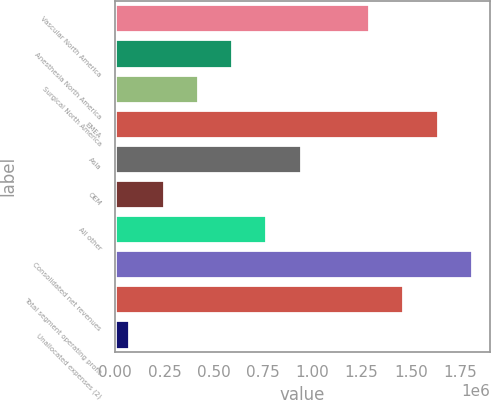<chart> <loc_0><loc_0><loc_500><loc_500><bar_chart><fcel>Vascular North America<fcel>Anesthesia North America<fcel>Surgical North America<fcel>EMEA<fcel>Asia<fcel>OEM<fcel>All other<fcel>Consolidated net revenues<fcel>Total segment operating profit<fcel>Unallocated expenses (2)<nl><fcel>1.28837e+06<fcel>593282<fcel>419509<fcel>1.63592e+06<fcel>940827<fcel>245737<fcel>767054<fcel>1.80969e+06<fcel>1.46214e+06<fcel>71964<nl></chart> 